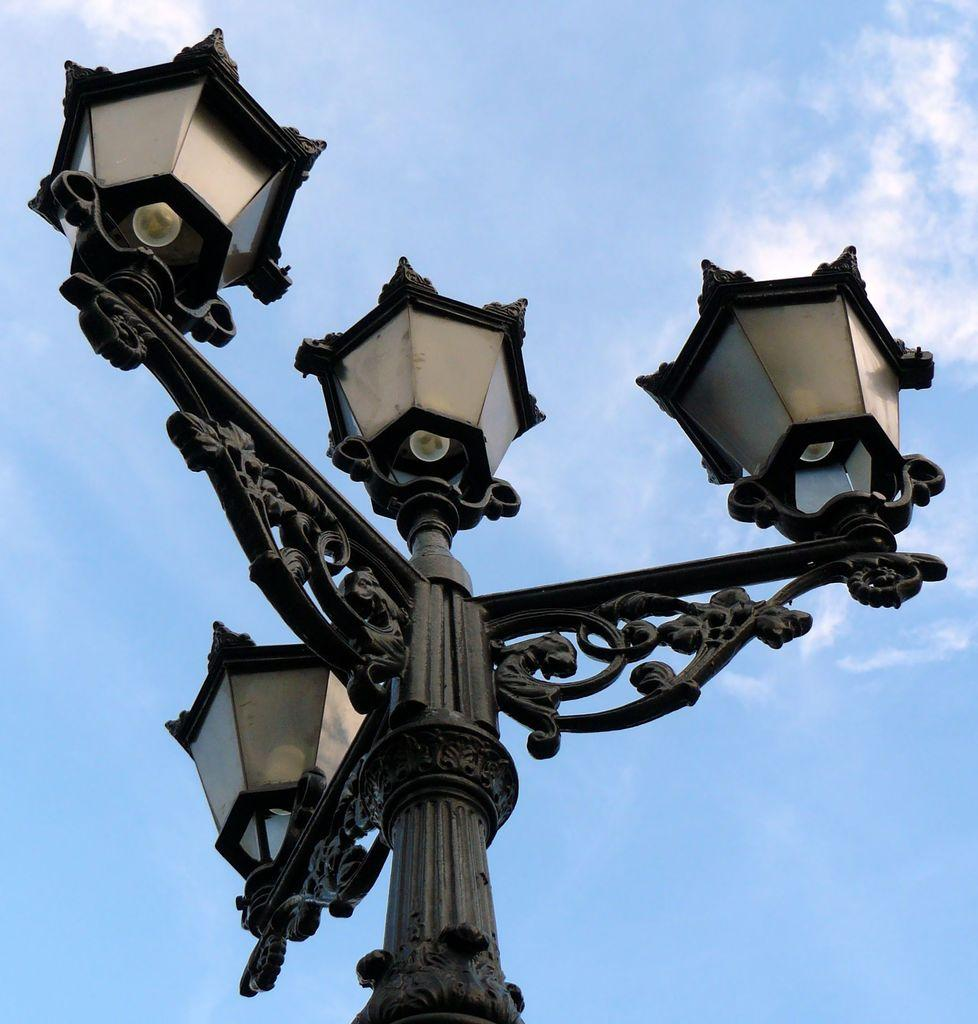What is the main object in the image? There is a pole in the image. What is attached to the pole? The pole has street lights on it. What might the pole be used for? The pole might be a lamp post. What can be seen in the background of the image? There are clouds visible in the background of the image. What is the color of the sky in the image? The sky is blue in color. How does the stranger plant the seed in the image? There is no stranger or seed present in the image. How does the pole increase the brightness in the image? The pole does not increase the brightness in the image; it is a stationary object with street lights attached to it. 